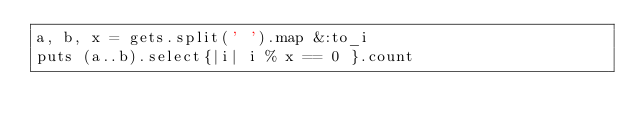Convert code to text. <code><loc_0><loc_0><loc_500><loc_500><_Ruby_>a, b, x = gets.split(' ').map &:to_i
puts (a..b).select{|i| i % x == 0 }.count
</code> 